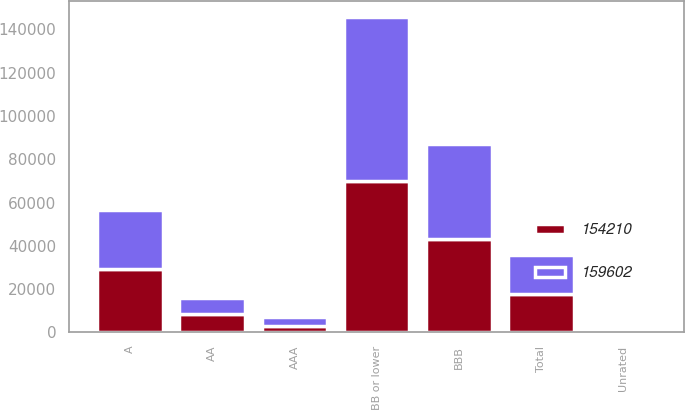<chart> <loc_0><loc_0><loc_500><loc_500><stacked_bar_chart><ecel><fcel>AAA<fcel>AA<fcel>A<fcel>BBB<fcel>BB or lower<fcel>Unrated<fcel>Total<nl><fcel>154210<fcel>3135<fcel>8375<fcel>29227<fcel>43151<fcel>69745<fcel>577<fcel>17793.5<nl><fcel>159602<fcel>4148<fcel>7716<fcel>27212<fcel>43937<fcel>76049<fcel>540<fcel>17793.5<nl></chart> 